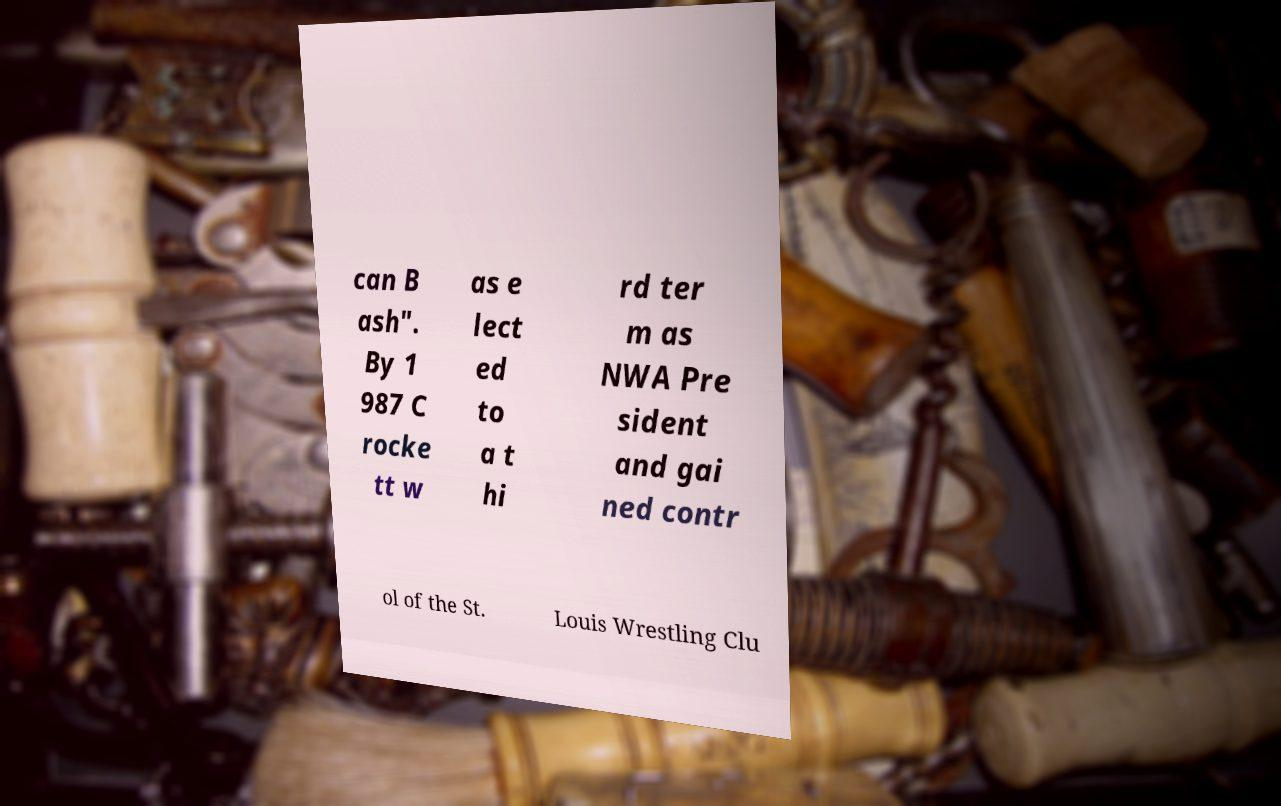Please read and relay the text visible in this image. What does it say? can B ash". By 1 987 C rocke tt w as e lect ed to a t hi rd ter m as NWA Pre sident and gai ned contr ol of the St. Louis Wrestling Clu 